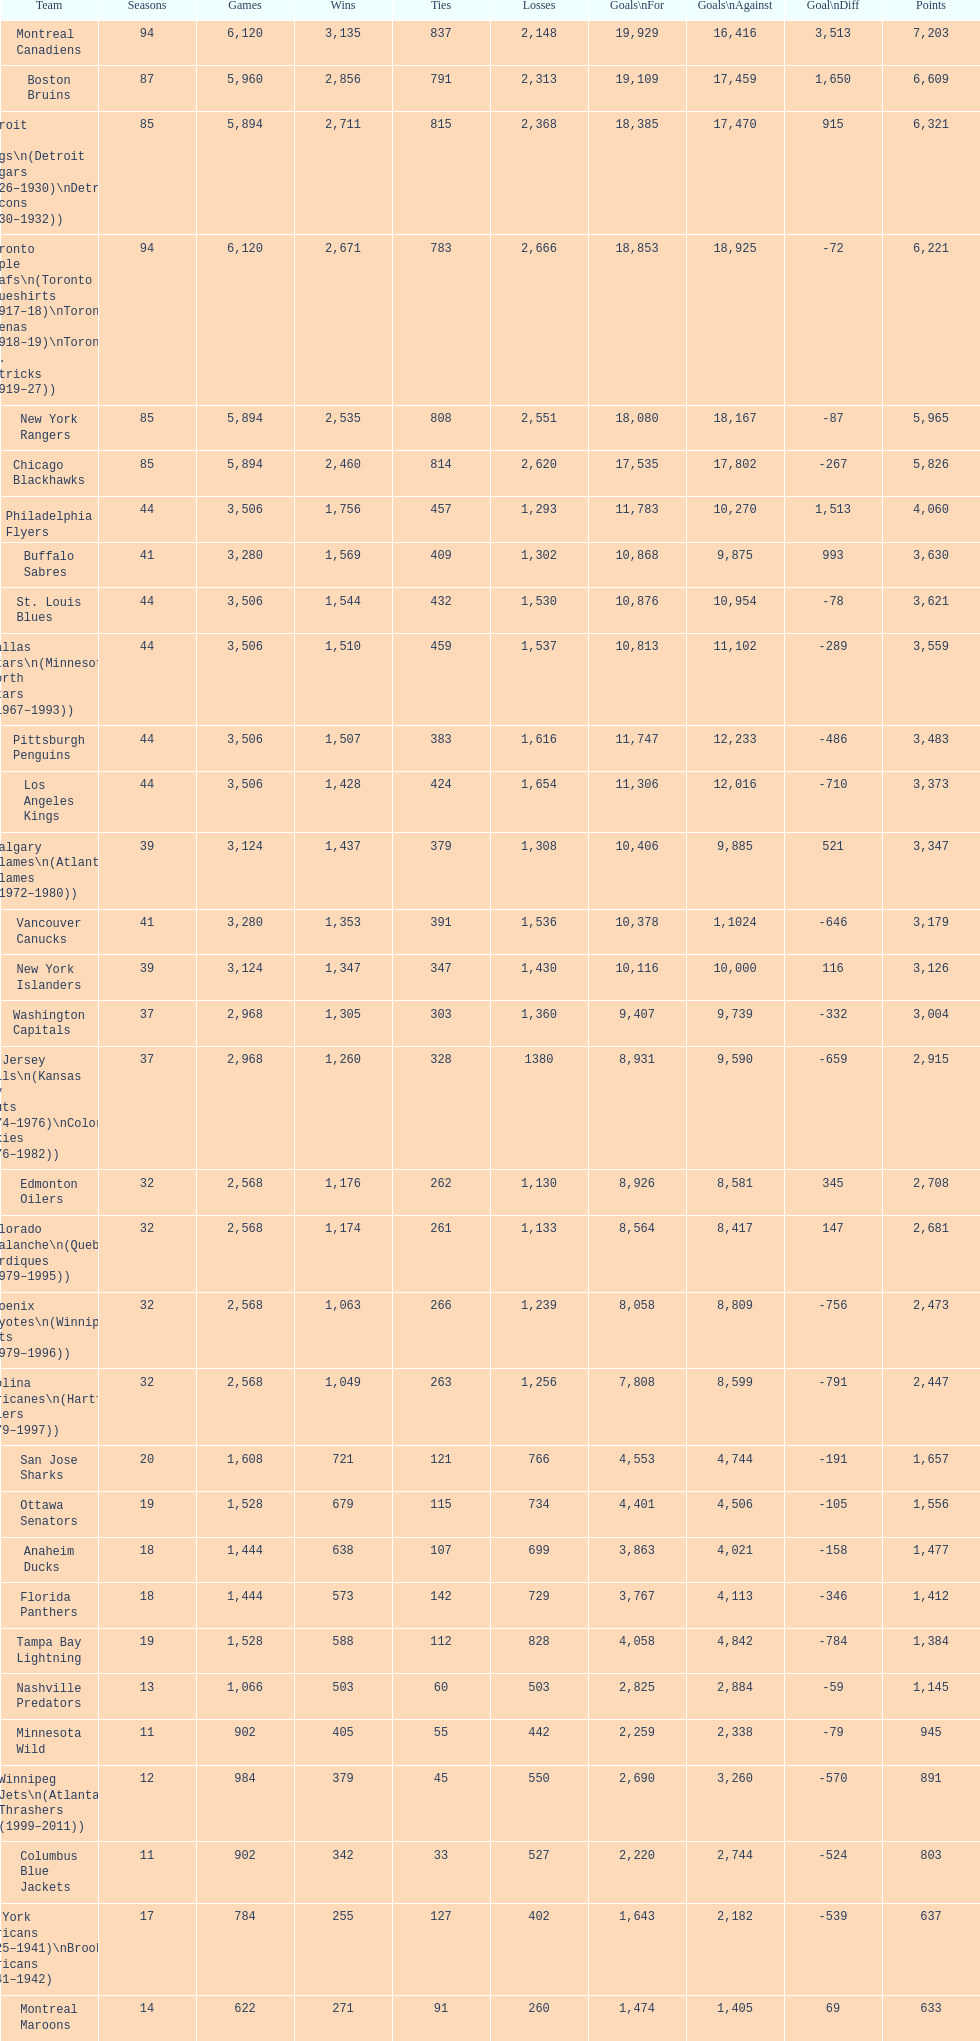What is the quantity of games that the vancouver canucks have triumphed in up to this moment? 1,353. 